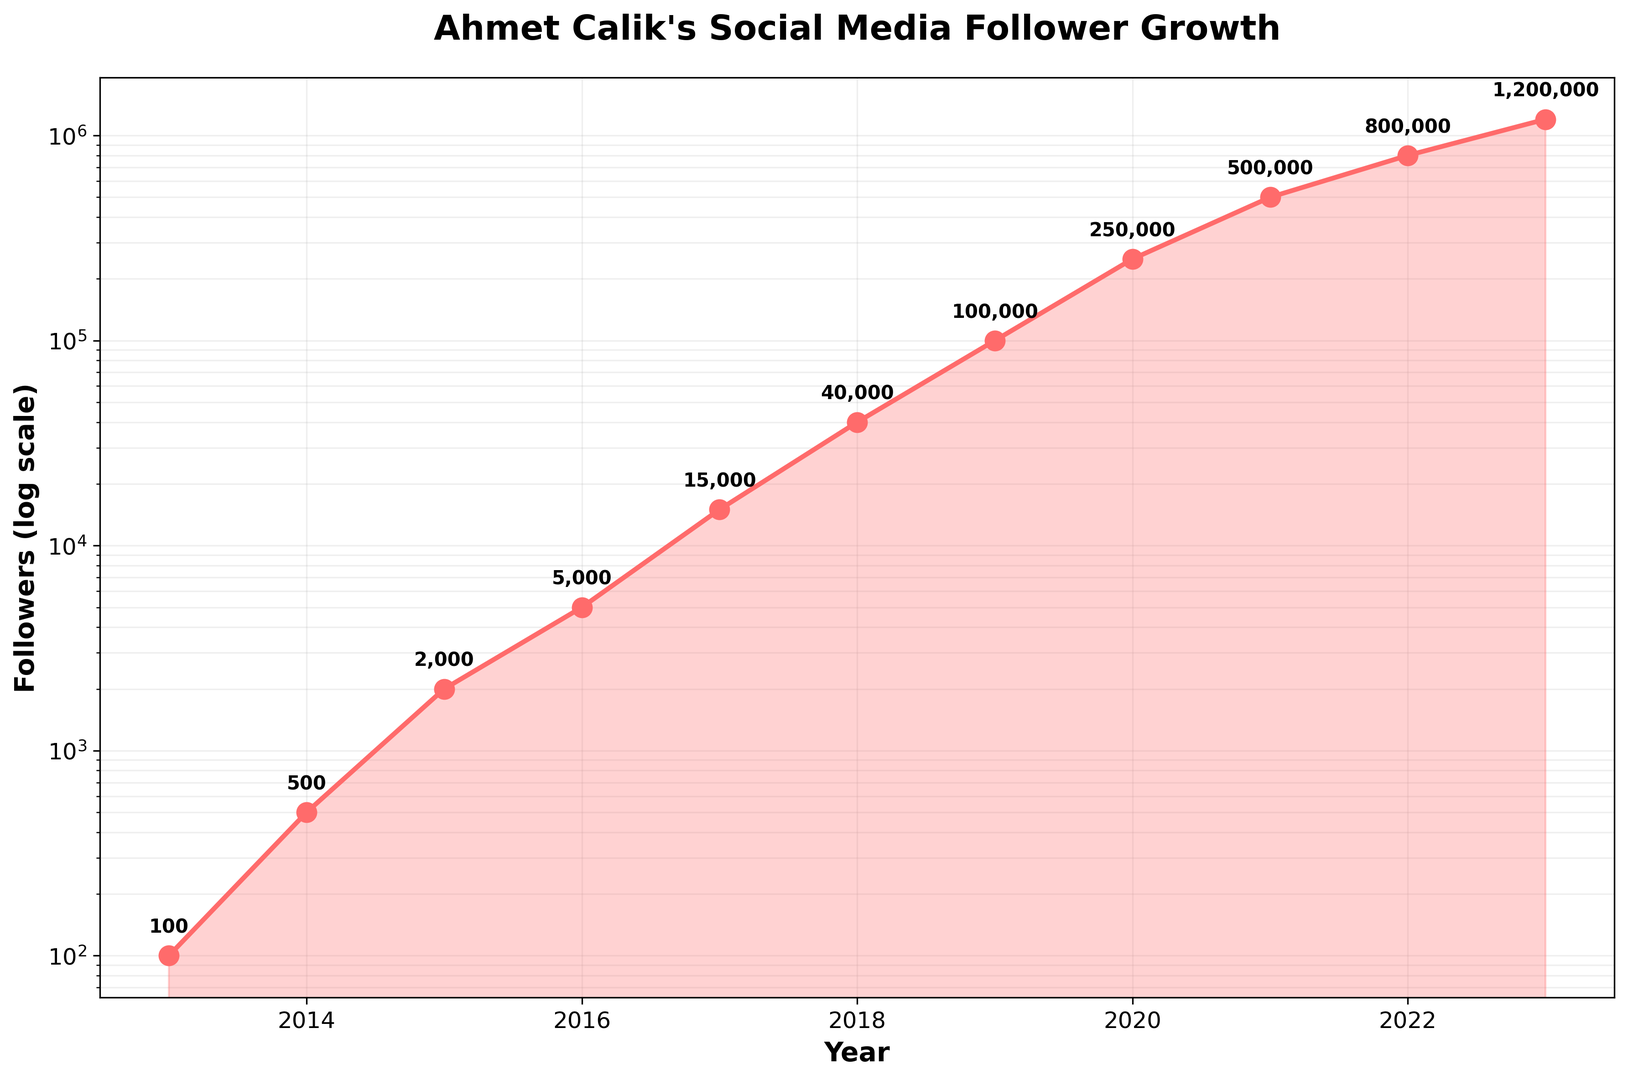what's the average number of followers in 2013 and 2023? To find the average, add the number of followers in 2013 (100) and 2023 (1,200,000), then divide by 2: (100 + 1,200,000) / 2 = 600,050
Answer: 600,050 How many more followers did Ahmet Calik have in 2023 compared to 2016? Subtract the number of followers in 2016 from the number of followers in 2023: 1,200,000 - 5,000 = 1,195,000
Answer: 1,195,000 Which year experienced the highest growth in the number of followers? To determine the year with the highest growth, visually compare the steepness of the line between consecutive data points. The steepest increase is between 2021 and 2022 (500,000 to 800,000).
Answer: 2021-2022 By how much did the followers increase between 2015 and 2019? To find this, subtract the number of followers in 2015 from the number of followers in 2019: 100,000 - 2,000 = 98,000
Answer: 98,000 How does the trend of follower growth change over the years? The visual shows an exponential increase, as seen by the upward curve. The increase is relatively slow initially but becomes steeper over time, indicating an accelerating growth.
Answer: Exponential increase Which year had exactly 5,000 followers? Locate the year corresponding to exactly 5,000 followers on the y-axis, which lines up with the year 2016.
Answer: 2016 What is the approximate ratio of followers in 2018 to those in 2015? To find the ratio, divide the followers in 2018 by those in 2015: 40,000 / 2,000 = 20
Answer: 20 Did the rate of follower increase ever decrease between consecutive years? Check for any segment of the line where the slope decreases between consecutive data points. Visually, the slope is consistently increasing or steady, meaning the rate did not reduce.
Answer: No How many times did the number of followers double between 2019 and 2023? Compare the follower counts and see how many times they double between the years: 100,000 in 2019 doubles to 200,000 (achieved by 2020). Then, 500,000 in 2021 and 1,000,000 hit shortly after 2022.
Answer: 2 times What is the overall follower increase from 2013 to 2023? Subtract the number of followers in 2013 from the number in 2023: 1,200,000 - 100 = 1,199,900
Answer: 1,199,900 